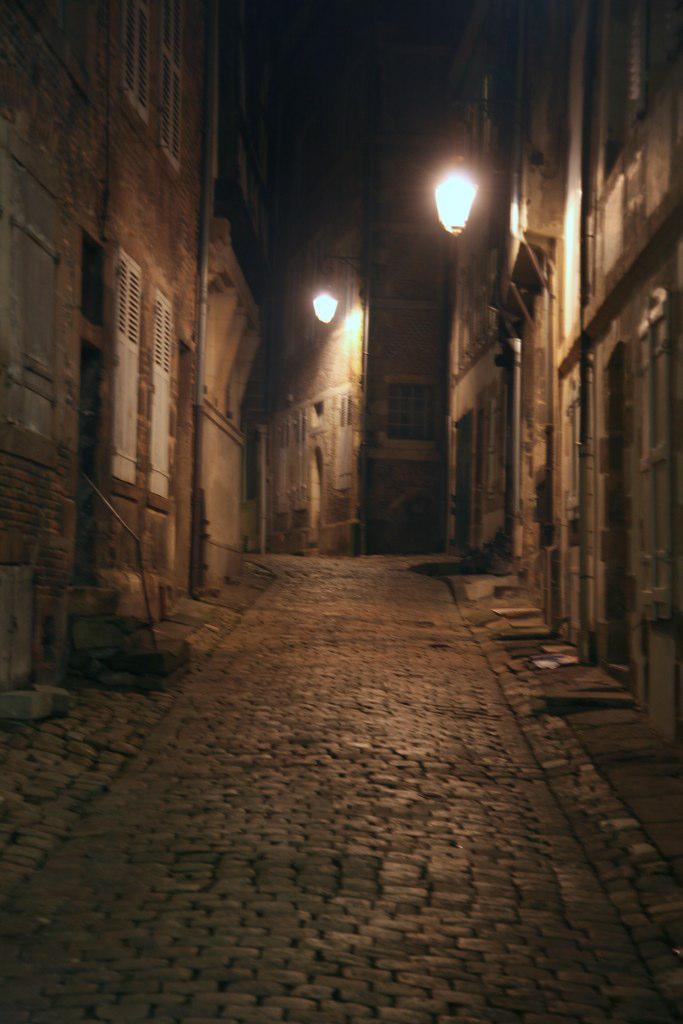In one or two sentences, can you explain what this image depicts? In this picture we can see the road beside there are some buildings and lights. 